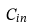<formula> <loc_0><loc_0><loc_500><loc_500>C _ { i n }</formula> 